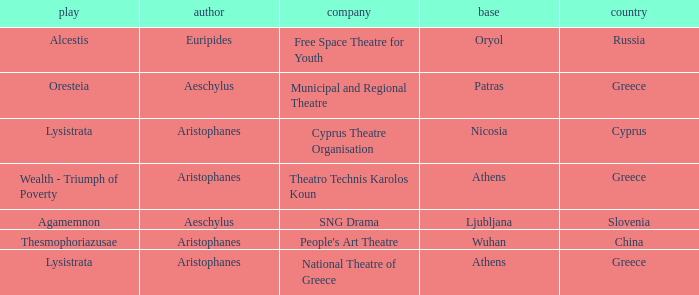What is the play when the company is cyprus theatre organisation? Lysistrata. 